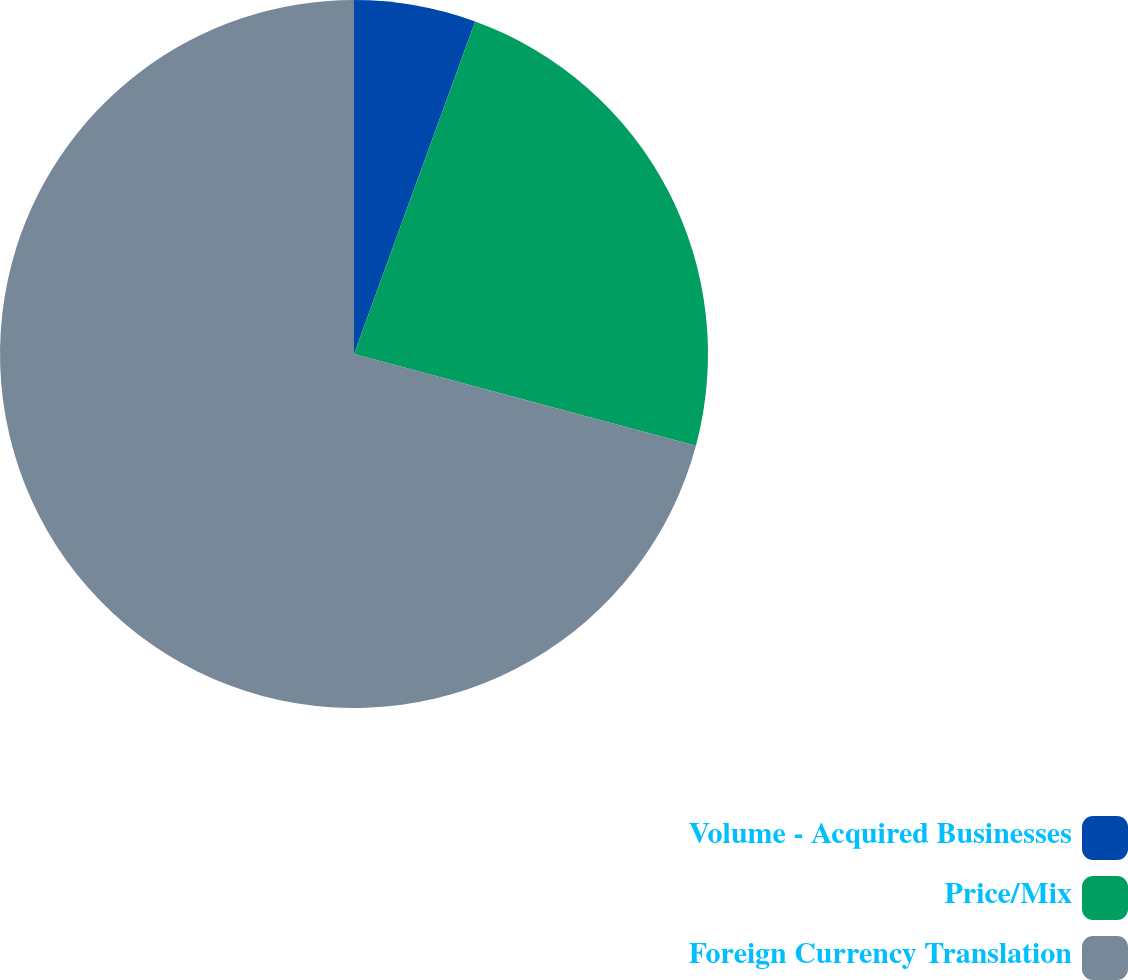Convert chart. <chart><loc_0><loc_0><loc_500><loc_500><pie_chart><fcel>Volume - Acquired Businesses<fcel>Price/Mix<fcel>Foreign Currency Translation<nl><fcel>5.56%<fcel>23.61%<fcel>70.83%<nl></chart> 